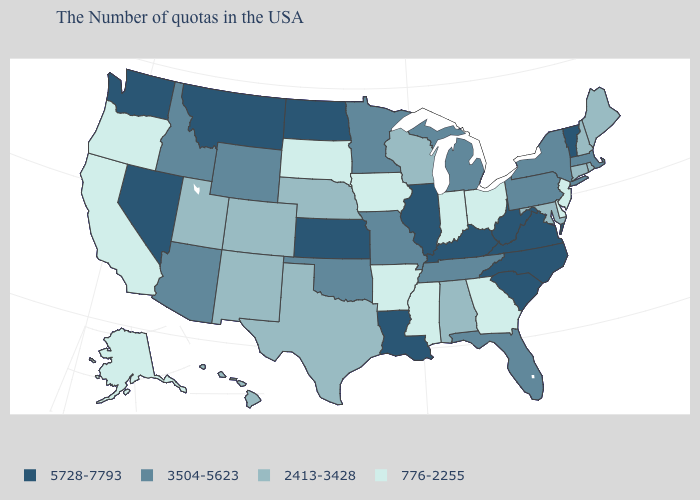Does Wisconsin have the lowest value in the MidWest?
Write a very short answer. No. What is the value of Arizona?
Be succinct. 3504-5623. How many symbols are there in the legend?
Be succinct. 4. Is the legend a continuous bar?
Answer briefly. No. What is the value of Tennessee?
Write a very short answer. 3504-5623. Among the states that border Louisiana , does Mississippi have the lowest value?
Keep it brief. Yes. Name the states that have a value in the range 3504-5623?
Concise answer only. Massachusetts, New York, Pennsylvania, Florida, Michigan, Tennessee, Missouri, Minnesota, Oklahoma, Wyoming, Arizona, Idaho. Which states hav the highest value in the MidWest?
Short answer required. Illinois, Kansas, North Dakota. Does the map have missing data?
Answer briefly. No. Name the states that have a value in the range 776-2255?
Quick response, please. New Jersey, Delaware, Ohio, Georgia, Indiana, Mississippi, Arkansas, Iowa, South Dakota, California, Oregon, Alaska. Does Nevada have the highest value in the USA?
Short answer required. Yes. What is the value of Utah?
Short answer required. 2413-3428. What is the value of Oklahoma?
Concise answer only. 3504-5623. Among the states that border Kansas , does Nebraska have the highest value?
Answer briefly. No. What is the value of New York?
Give a very brief answer. 3504-5623. 